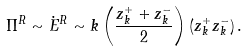<formula> <loc_0><loc_0><loc_500><loc_500>\Pi ^ { R } \sim \dot { E } ^ { R } \sim k \left ( \frac { z _ { k } ^ { + } + z _ { k } ^ { - } } 2 \right ) \left ( z _ { k } ^ { + } z _ { k } ^ { - } \right ) .</formula> 